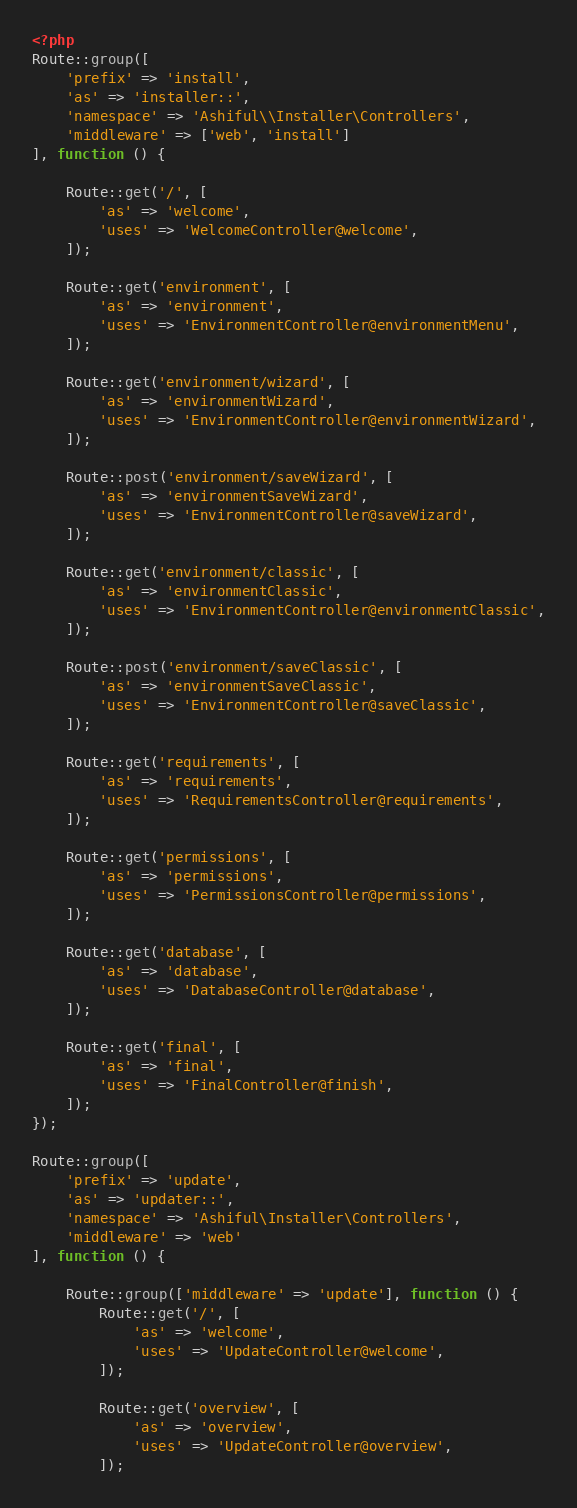Convert code to text. <code><loc_0><loc_0><loc_500><loc_500><_PHP_><?php
Route::group([
    'prefix' => 'install',
    'as' => 'installer::',
    'namespace' => 'Ashiful\\Installer\Controllers',
    'middleware' => ['web', 'install']
], function () {

    Route::get('/', [
        'as' => 'welcome',
        'uses' => 'WelcomeController@welcome',
    ]);

    Route::get('environment', [
        'as' => 'environment',
        'uses' => 'EnvironmentController@environmentMenu',
    ]);

    Route::get('environment/wizard', [
        'as' => 'environmentWizard',
        'uses' => 'EnvironmentController@environmentWizard',
    ]);

    Route::post('environment/saveWizard', [
        'as' => 'environmentSaveWizard',
        'uses' => 'EnvironmentController@saveWizard',
    ]);

    Route::get('environment/classic', [
        'as' => 'environmentClassic',
        'uses' => 'EnvironmentController@environmentClassic',
    ]);

    Route::post('environment/saveClassic', [
        'as' => 'environmentSaveClassic',
        'uses' => 'EnvironmentController@saveClassic',
    ]);

    Route::get('requirements', [
        'as' => 'requirements',
        'uses' => 'RequirementsController@requirements',
    ]);

    Route::get('permissions', [
        'as' => 'permissions',
        'uses' => 'PermissionsController@permissions',
    ]);

    Route::get('database', [
        'as' => 'database',
        'uses' => 'DatabaseController@database',
    ]);

    Route::get('final', [
        'as' => 'final',
        'uses' => 'FinalController@finish',
    ]);
});

Route::group([
    'prefix' => 'update',
    'as' => 'updater::',
    'namespace' => 'Ashiful\Installer\Controllers',
    'middleware' => 'web'
], function () {

    Route::group(['middleware' => 'update'], function () {
        Route::get('/', [
            'as' => 'welcome',
            'uses' => 'UpdateController@welcome',
        ]);

        Route::get('overview', [
            'as' => 'overview',
            'uses' => 'UpdateController@overview',
        ]);
</code> 